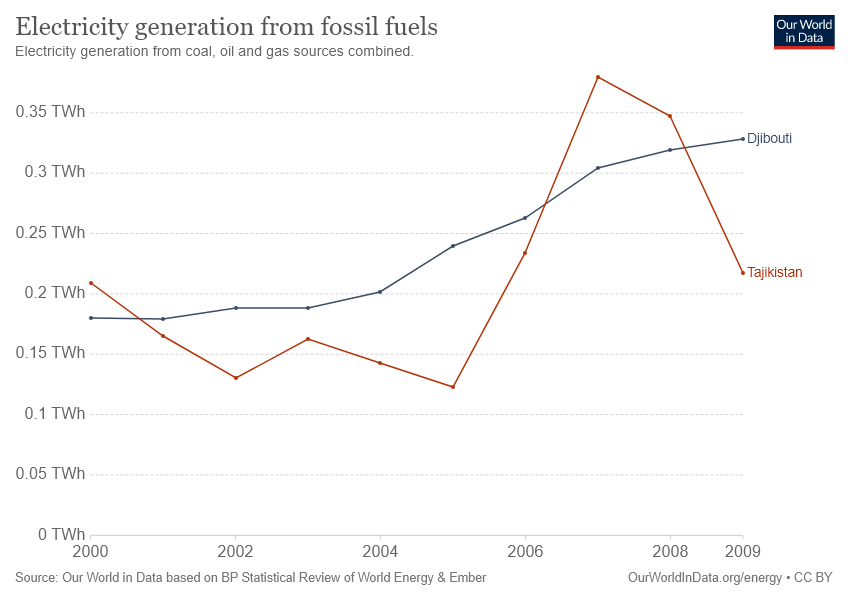Indicate a few pertinent items in this graphic. The given line graph compares two countries, Djibouti and Tajikistan. In 2009, Djibouti generated the highest amount of electricity from fossil fuels among all years on record. 